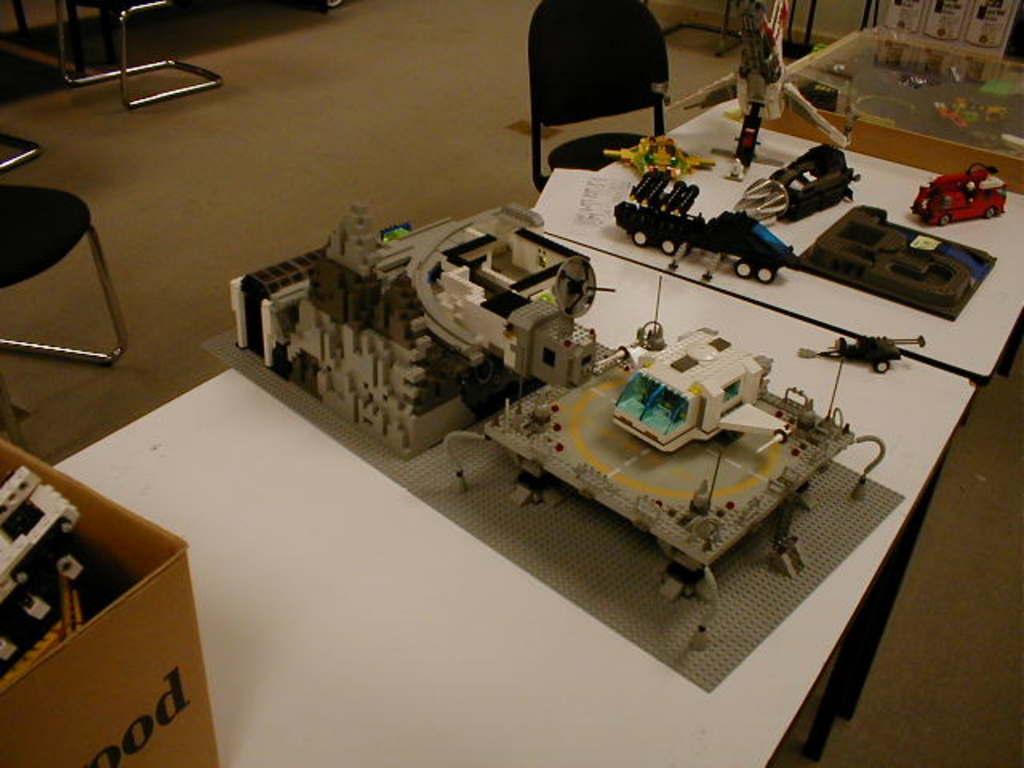How would you summarize this image in a sentence or two? In this image I can see few tables and on it I can see a box and number of equipment. In the background I can see few chairs. 